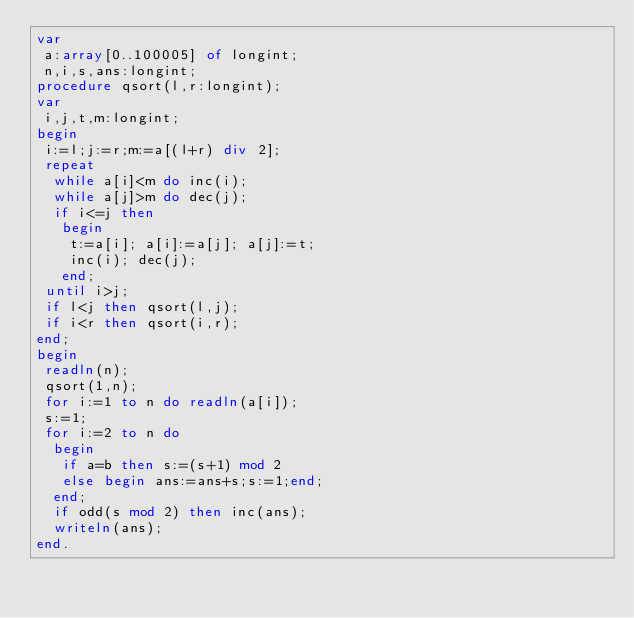Convert code to text. <code><loc_0><loc_0><loc_500><loc_500><_Pascal_>var
 a:array[0..100005] of longint;
 n,i,s,ans:longint;
procedure qsort(l,r:longint);
var
 i,j,t,m:longint;
begin
 i:=l;j:=r;m:=a[(l+r) div 2];
 repeat
  while a[i]<m do inc(i);
  while a[j]>m do dec(j);
  if i<=j then
   begin
    t:=a[i]; a[i]:=a[j]; a[j]:=t; 
    inc(i); dec(j);
   end;  
 until i>j;
 if l<j then qsort(l,j);
 if i<r then qsort(i,r);
end; 
begin
 readln(n);
 qsort(1,n);
 for i:=1 to n do readln(a[i]);
 s:=1;
 for i:=2 to n do
  begin
   if a=b then s:=(s+1) mod 2
   else begin ans:=ans+s;s:=1;end;
  end;
  if odd(s mod 2) then inc(ans);
  writeln(ans);
end.</code> 